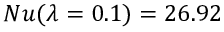<formula> <loc_0><loc_0><loc_500><loc_500>N u ( \lambda = 0 . 1 ) = 2 6 . 9 2</formula> 